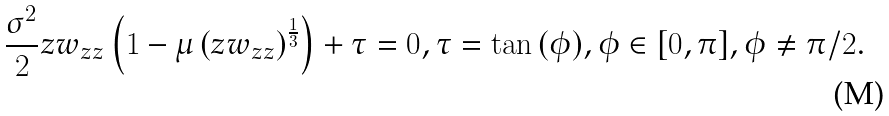Convert formula to latex. <formula><loc_0><loc_0><loc_500><loc_500>\frac { \sigma ^ { 2 } } { 2 } z w _ { z z } \left ( 1 - \mu \left ( z w _ { z z } \right ) ^ { \frac { 1 } { 3 } } \right ) + \tau = 0 , \tau = \tan { ( \phi ) } , { \phi } \in [ 0 , \pi ] , { \phi } \ne \pi / 2 .</formula> 